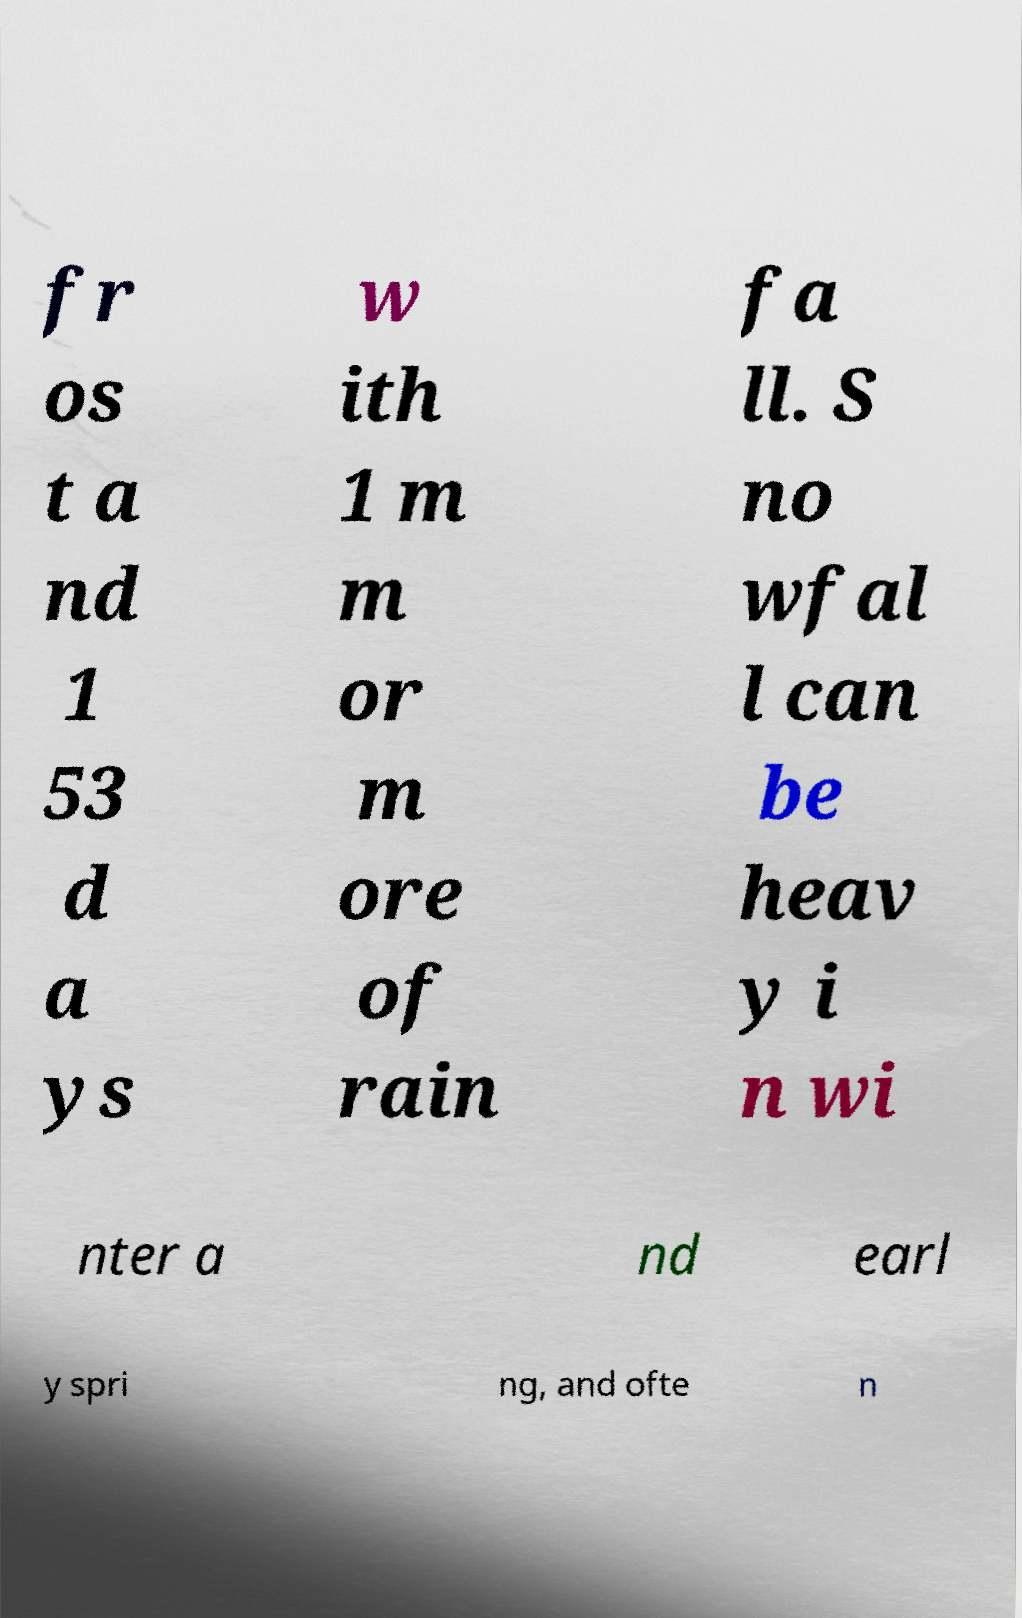I need the written content from this picture converted into text. Can you do that? fr os t a nd 1 53 d a ys w ith 1 m m or m ore of rain fa ll. S no wfal l can be heav y i n wi nter a nd earl y spri ng, and ofte n 